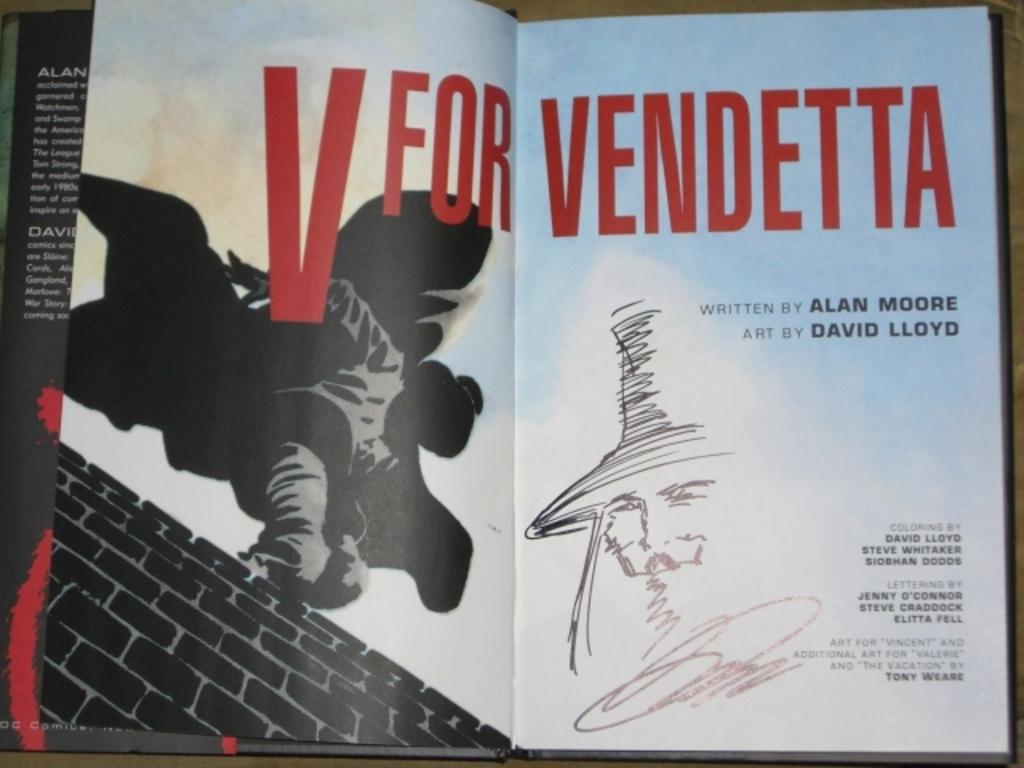Provide a one-sentence caption for the provided image. Open book that says, "V for Vendetta written by Alan Moore. 